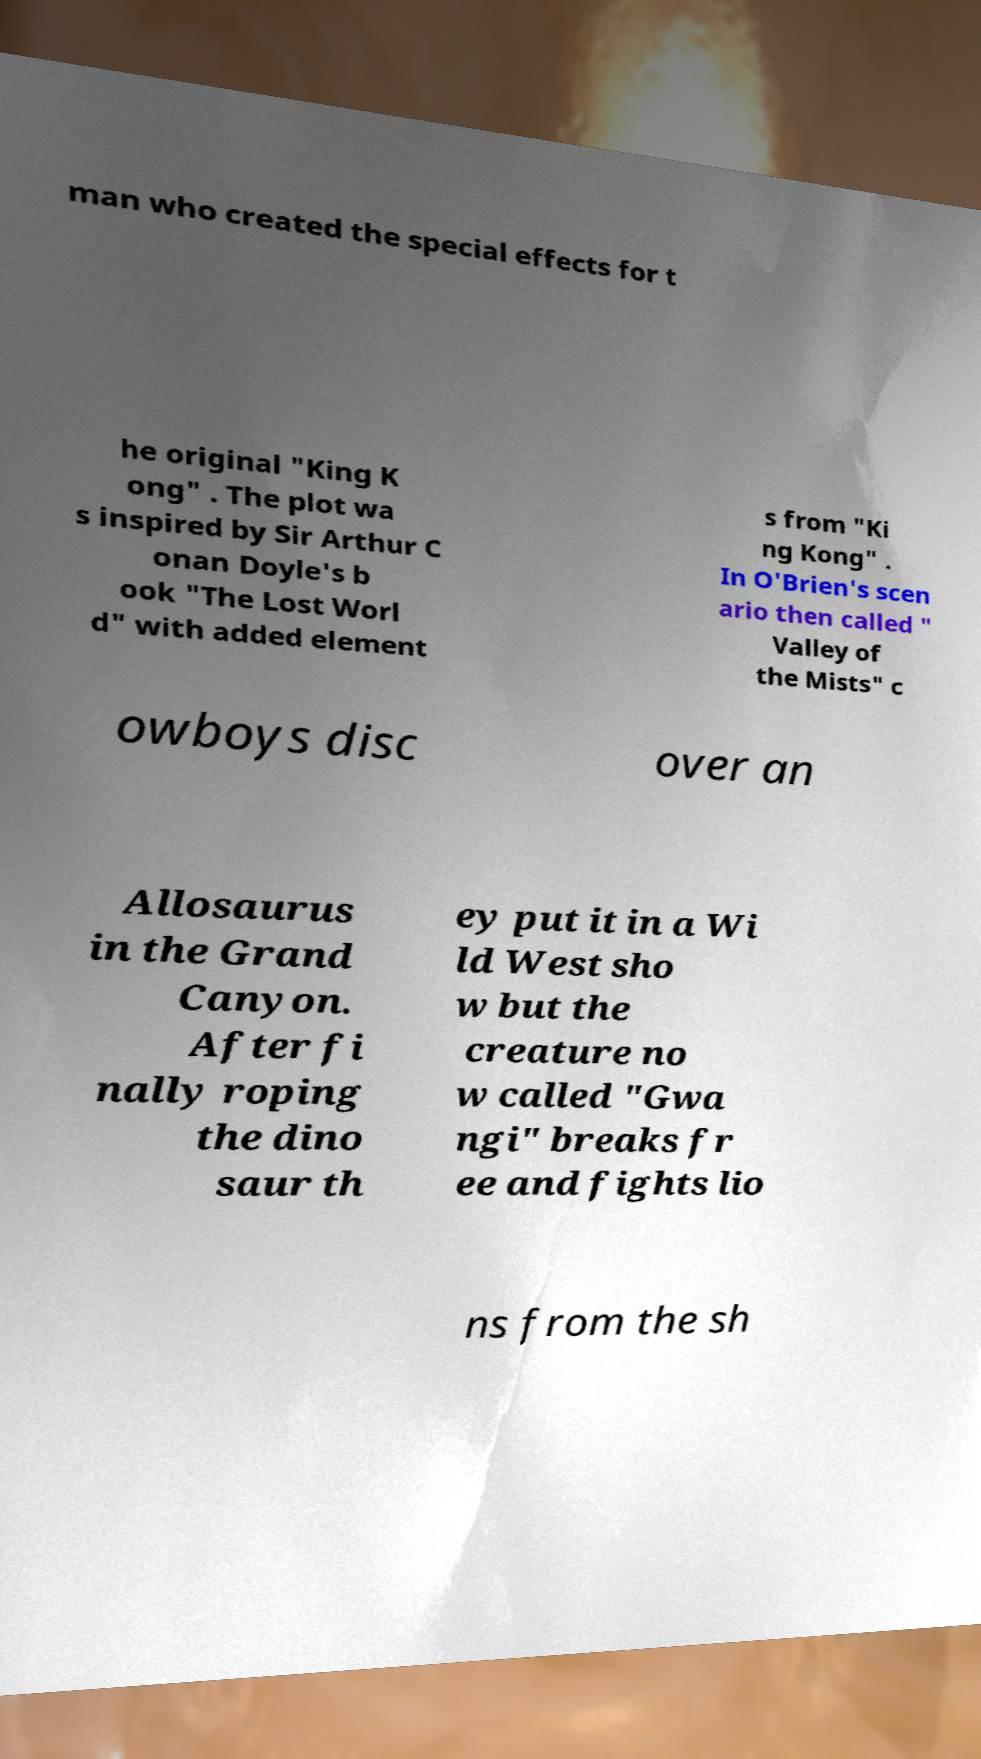Could you assist in decoding the text presented in this image and type it out clearly? man who created the special effects for t he original "King K ong" . The plot wa s inspired by Sir Arthur C onan Doyle's b ook "The Lost Worl d" with added element s from "Ki ng Kong" . In O'Brien's scen ario then called " Valley of the Mists" c owboys disc over an Allosaurus in the Grand Canyon. After fi nally roping the dino saur th ey put it in a Wi ld West sho w but the creature no w called "Gwa ngi" breaks fr ee and fights lio ns from the sh 